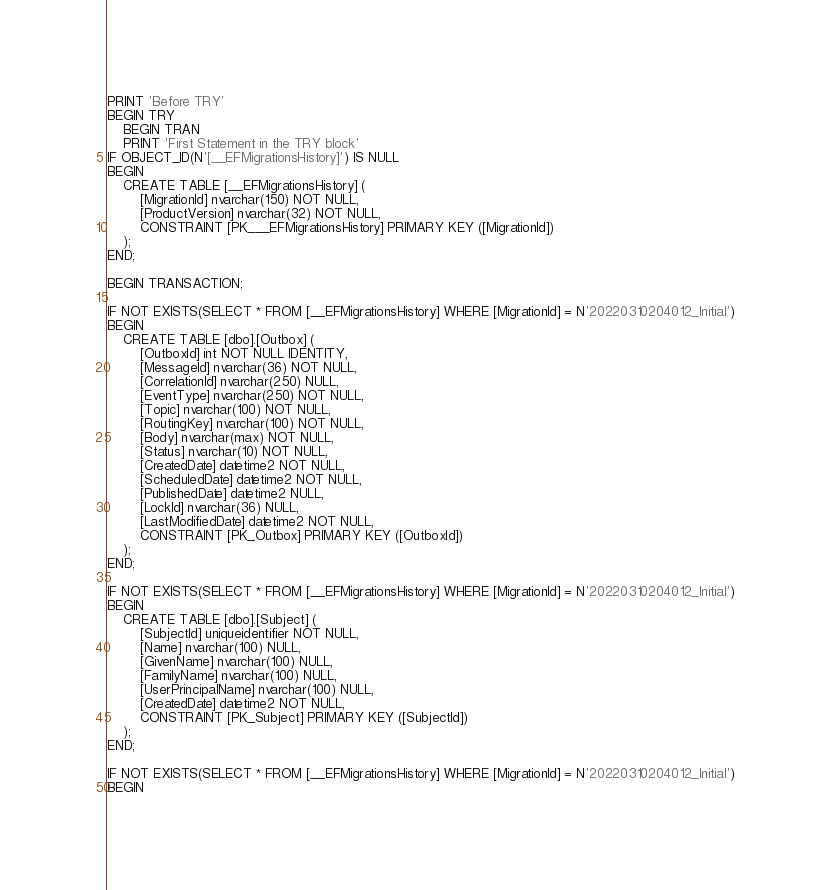Convert code to text. <code><loc_0><loc_0><loc_500><loc_500><_SQL_>PRINT 'Before TRY'
BEGIN TRY
	BEGIN TRAN
	PRINT 'First Statement in the TRY block'
IF OBJECT_ID(N'[__EFMigrationsHistory]') IS NULL
BEGIN
    CREATE TABLE [__EFMigrationsHistory] (
        [MigrationId] nvarchar(150) NOT NULL,
        [ProductVersion] nvarchar(32) NOT NULL,
        CONSTRAINT [PK___EFMigrationsHistory] PRIMARY KEY ([MigrationId])
    );
END;

BEGIN TRANSACTION;

IF NOT EXISTS(SELECT * FROM [__EFMigrationsHistory] WHERE [MigrationId] = N'20220310204012_Initial')
BEGIN
    CREATE TABLE [dbo].[Outbox] (
        [OutboxId] int NOT NULL IDENTITY,
        [MessageId] nvarchar(36) NOT NULL,
        [CorrelationId] nvarchar(250) NULL,
        [EventType] nvarchar(250) NOT NULL,
        [Topic] nvarchar(100) NOT NULL,
        [RoutingKey] nvarchar(100) NOT NULL,
        [Body] nvarchar(max) NOT NULL,
        [Status] nvarchar(10) NOT NULL,
        [CreatedDate] datetime2 NOT NULL,
        [ScheduledDate] datetime2 NOT NULL,
        [PublishedDate] datetime2 NULL,
        [LockId] nvarchar(36) NULL,
        [LastModifiedDate] datetime2 NOT NULL,
        CONSTRAINT [PK_Outbox] PRIMARY KEY ([OutboxId])
    );
END;

IF NOT EXISTS(SELECT * FROM [__EFMigrationsHistory] WHERE [MigrationId] = N'20220310204012_Initial')
BEGIN
    CREATE TABLE [dbo].[Subject] (
        [SubjectId] uniqueidentifier NOT NULL,
        [Name] nvarchar(100) NULL,
        [GivenName] nvarchar(100) NULL,
        [FamilyName] nvarchar(100) NULL,
        [UserPrincipalName] nvarchar(100) NULL,
        [CreatedDate] datetime2 NOT NULL,
        CONSTRAINT [PK_Subject] PRIMARY KEY ([SubjectId])
    );
END;

IF NOT EXISTS(SELECT * FROM [__EFMigrationsHistory] WHERE [MigrationId] = N'20220310204012_Initial')
BEGIN</code> 